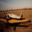Can you describe the design features of this airplane that make it suitable for long-haul flights? The airplane in the image is equipped with several design features ideal for long-haul flights. Firstly, the use of swept wings helps in reducing aerodynamic drag at higher speeds, which is crucial for the efficiency of transcontinental travel. Secondly, the aircraft features turbofan engines, which are capable of providing the necessary thrust while maintaining fuel efficiency over long distances. Additionally, the streamlined fuselage minimizes air resistance, and the presence of multiple exit doors and larger window panes indicate enhanced passenger comfort and safety standards, which are vital for long-duration flights. 